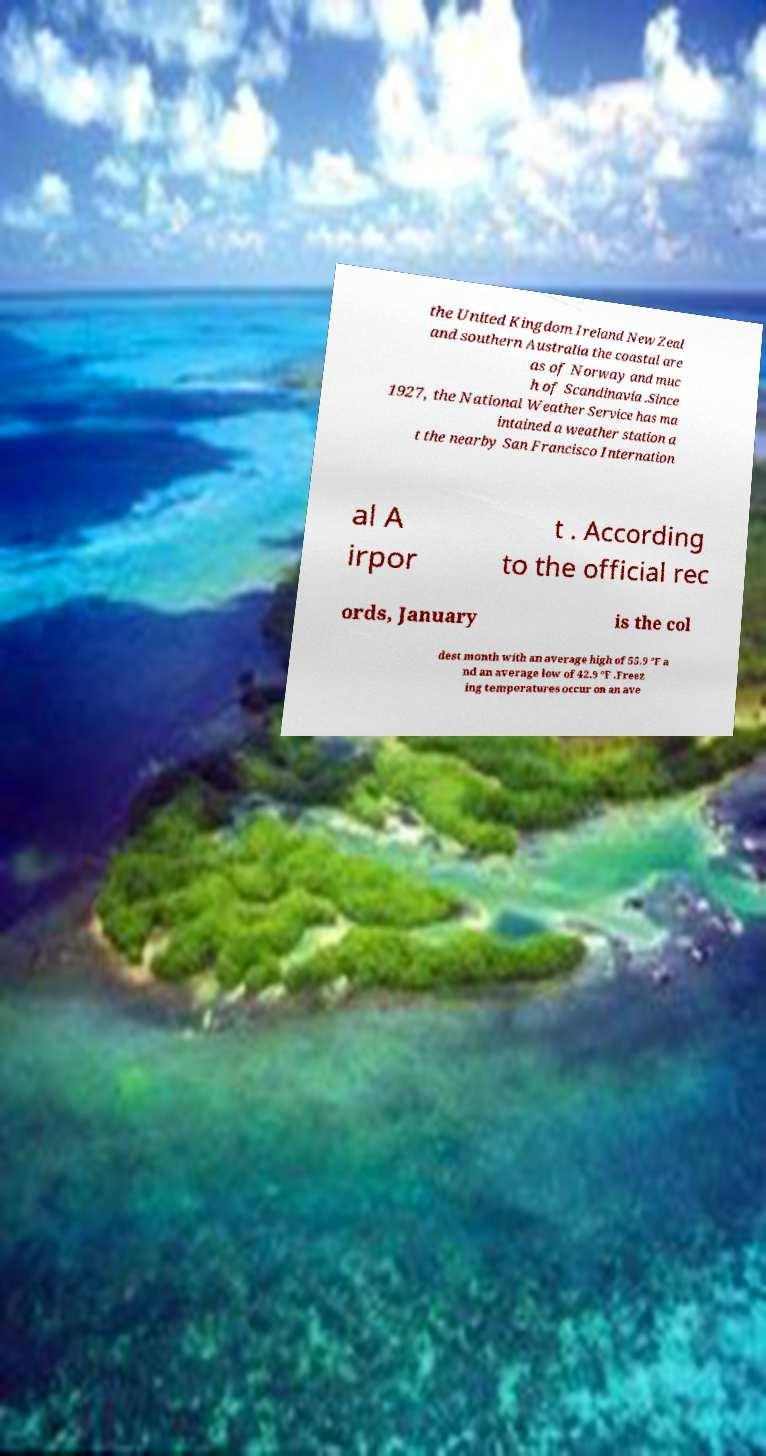What messages or text are displayed in this image? I need them in a readable, typed format. the United Kingdom Ireland New Zeal and southern Australia the coastal are as of Norway and muc h of Scandinavia .Since 1927, the National Weather Service has ma intained a weather station a t the nearby San Francisco Internation al A irpor t . According to the official rec ords, January is the col dest month with an average high of 55.9 °F a nd an average low of 42.9 °F .Freez ing temperatures occur on an ave 